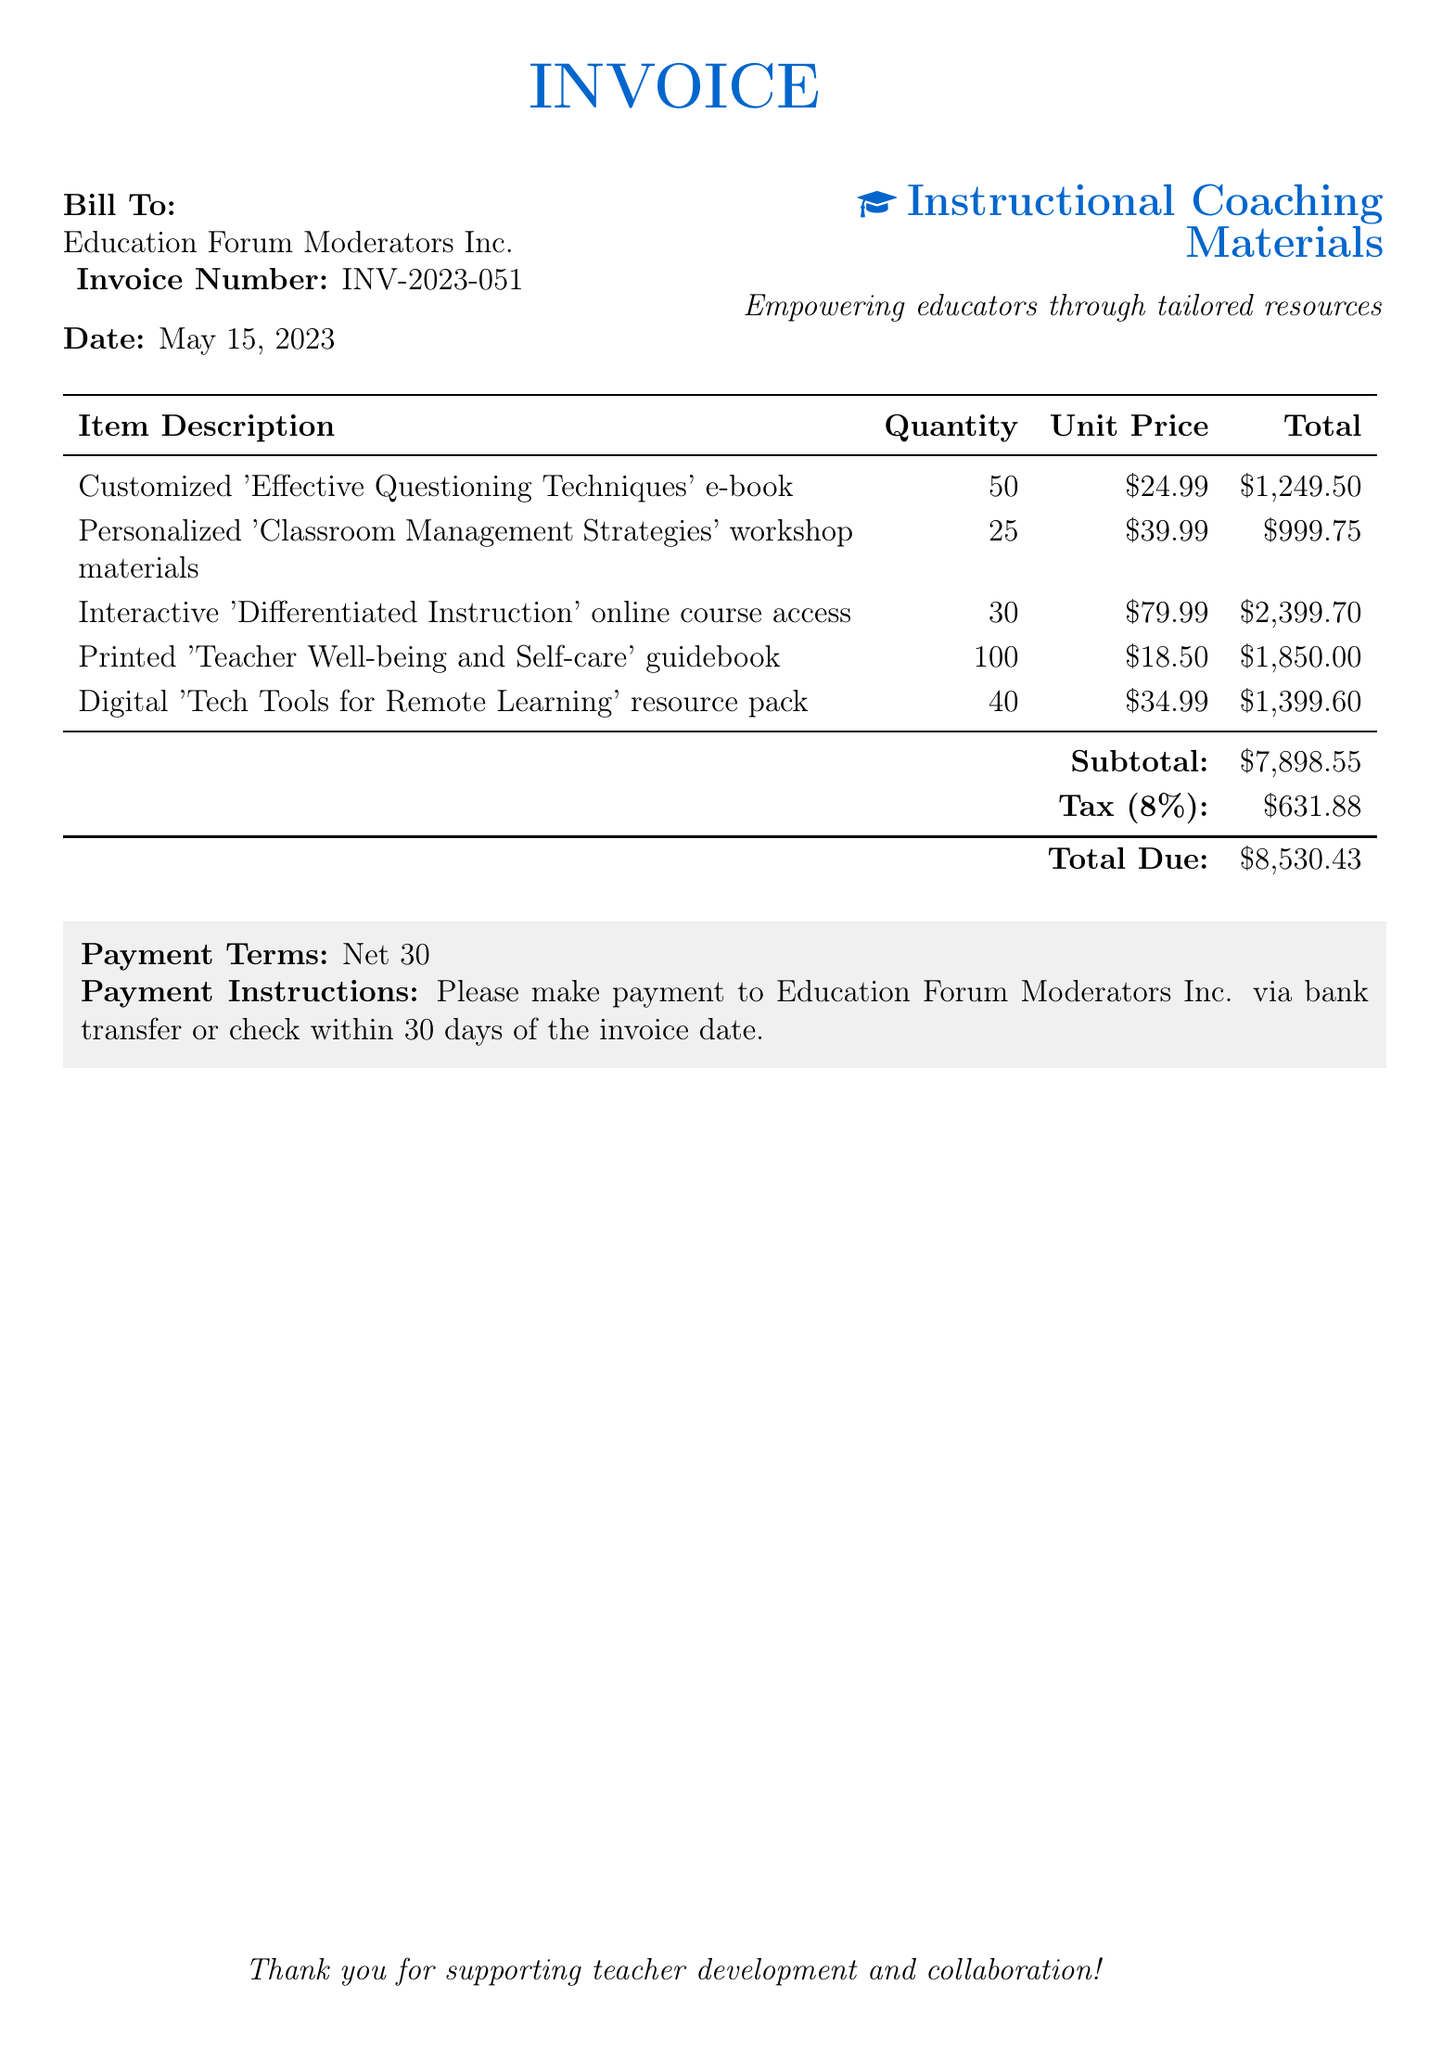What is the invoice number? The invoice number is clearly listed in the document for reference, which is INV-2023-051.
Answer: INV-2023-051 What is the total due amount? The total amount due at the bottom of the invoice is described, which sums up all charges including tax, amounting to $8,530.43.
Answer: $8,530.43 How many quantities of the 'Effective Questioning Techniques' e-book were ordered? The quantity of the e-book is detailed in the itemized section of the bill, which states 50 units were ordered.
Answer: 50 What is the unit price of the 'Classroom Management Strategies' workshop materials? The document specifies the unit price for the workshop materials, which is listed as $39.99.
Answer: $39.99 What is the tax percentage applied to the subtotal? The tax rate is mentioned in the document and is stated as 8%.
Answer: 8% What is the subtotal amount before tax? The subtotal amount, which is the total of the items before tax, is shown in the bill as $7,898.55.
Answer: $7,898.55 What type of document is this? The primary purpose and classification of the document is evident from the header, which is classified as an invoice.
Answer: Invoice What payment terms are specified in the document? The payment terms for this invoice are provided at the bottom and are indicated as Net 30.
Answer: Net 30 How many printed 'Teacher Well-being and Self-care' guidebooks were included in the order? The quantity of the printed guidebooks is stated in the itemized section, which indicates 100 units were included in the order.
Answer: 100 